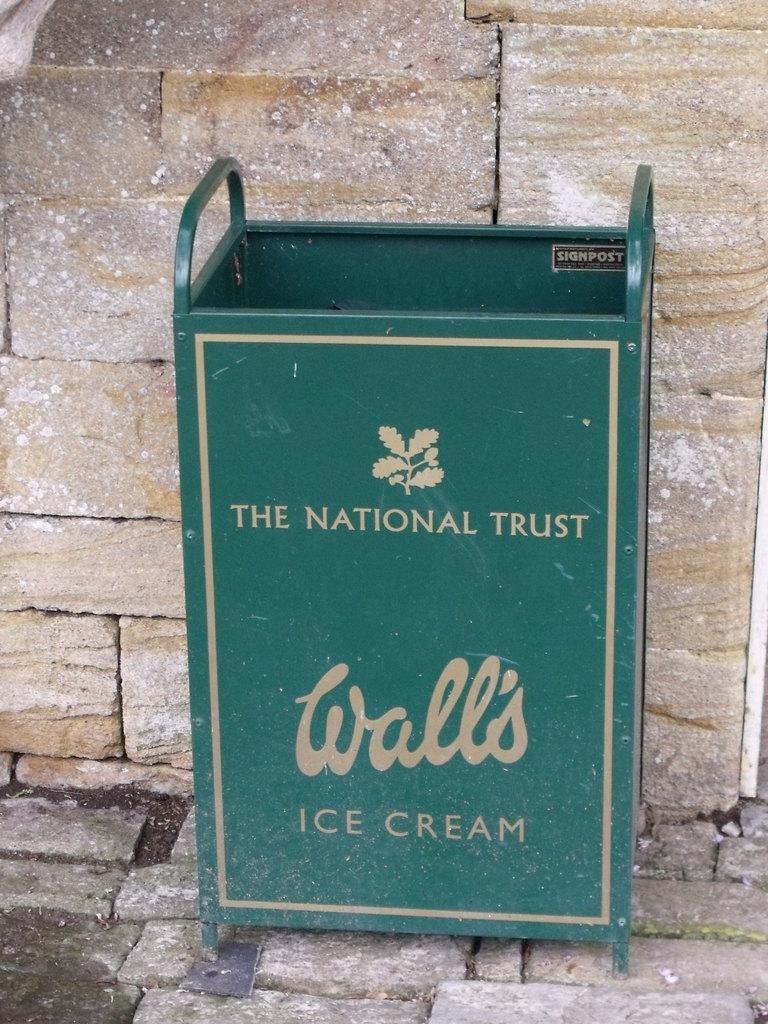The national trust makes what?
Your answer should be very brief. Ice cream. What brand is this ice cream?
Keep it short and to the point. Wall's. 